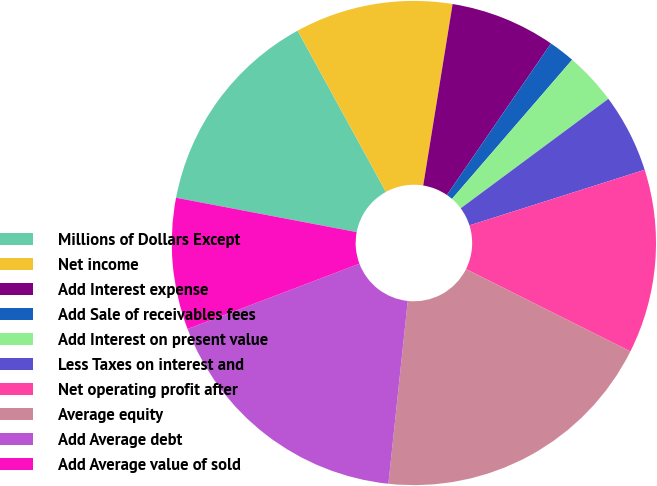<chart> <loc_0><loc_0><loc_500><loc_500><pie_chart><fcel>Millions of Dollars Except<fcel>Net income<fcel>Add Interest expense<fcel>Add Sale of receivables fees<fcel>Add Interest on present value<fcel>Less Taxes on interest and<fcel>Net operating profit after<fcel>Average equity<fcel>Add Average debt<fcel>Add Average value of sold<nl><fcel>14.03%<fcel>10.53%<fcel>7.02%<fcel>1.76%<fcel>3.51%<fcel>5.26%<fcel>12.28%<fcel>19.29%<fcel>17.54%<fcel>8.77%<nl></chart> 